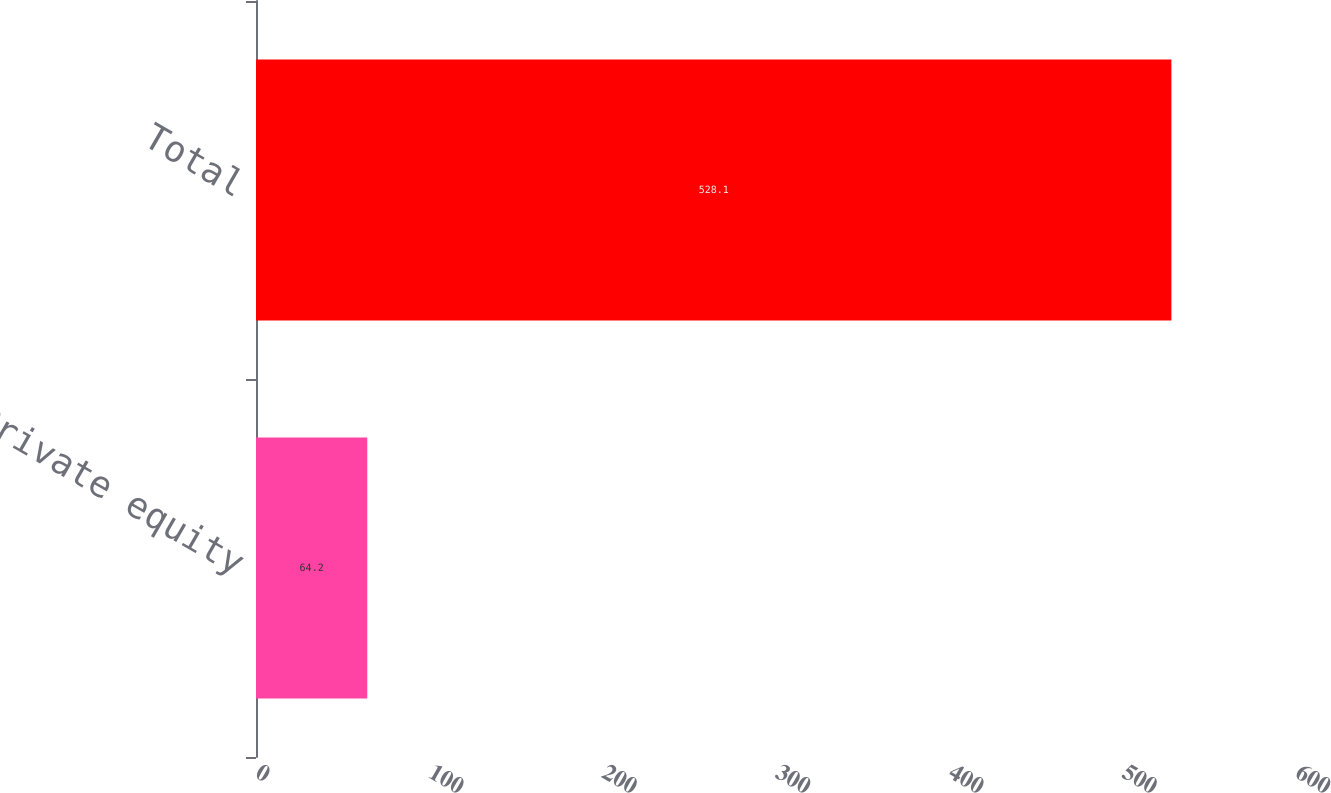Convert chart to OTSL. <chart><loc_0><loc_0><loc_500><loc_500><bar_chart><fcel>Private equity<fcel>Total<nl><fcel>64.2<fcel>528.1<nl></chart> 